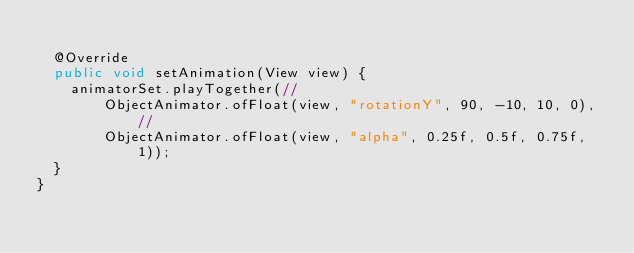<code> <loc_0><loc_0><loc_500><loc_500><_Java_>
	@Override
	public void setAnimation(View view) {
		animatorSet.playTogether(//
				ObjectAnimator.ofFloat(view, "rotationY", 90, -10, 10, 0),//
				ObjectAnimator.ofFloat(view, "alpha", 0.25f, 0.5f, 0.75f, 1));
	}
}
</code> 